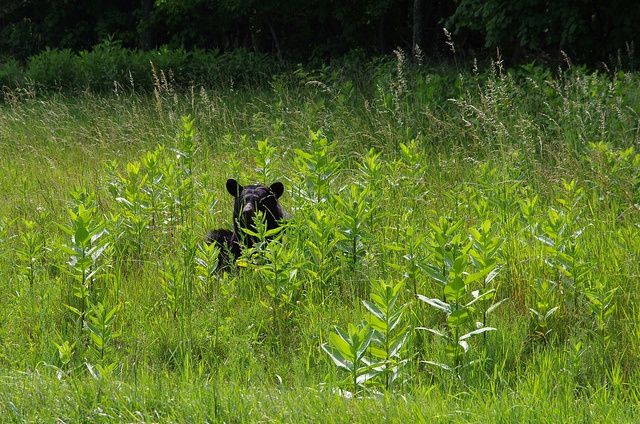Describe the objects in this image and their specific colors. I can see a bear in black, darkgreen, gray, and olive tones in this image. 